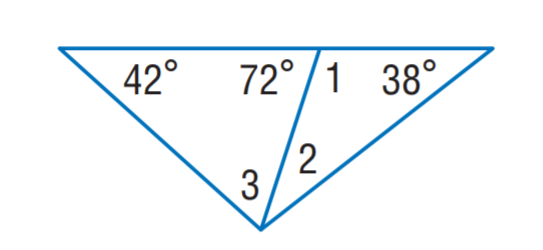Answer the mathemtical geometry problem and directly provide the correct option letter.
Question: Find m \angle 2.
Choices: A: 34 B: 38 C: 42 D: 66 A 